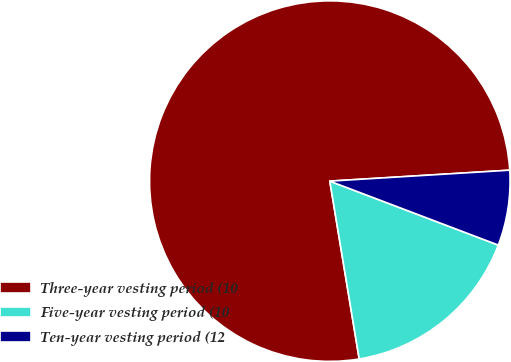Convert chart to OTSL. <chart><loc_0><loc_0><loc_500><loc_500><pie_chart><fcel>Three-year vesting period (10<fcel>Five-year vesting period (10<fcel>Ten-year vesting period (12<nl><fcel>76.64%<fcel>16.62%<fcel>6.74%<nl></chart> 